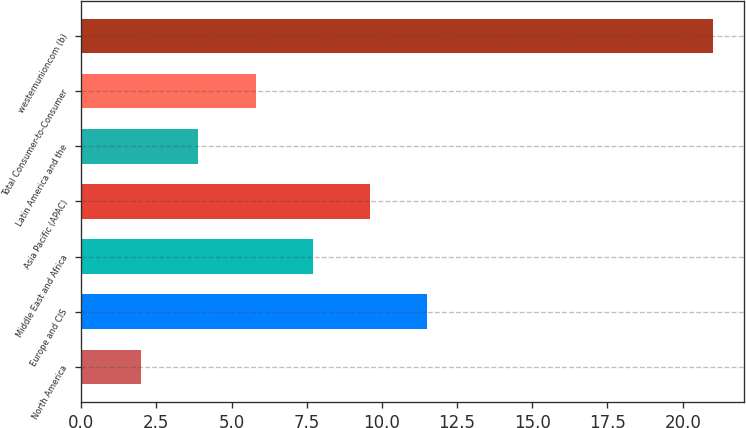<chart> <loc_0><loc_0><loc_500><loc_500><bar_chart><fcel>North America<fcel>Europe and CIS<fcel>Middle East and Africa<fcel>Asia Pacific (APAC)<fcel>Latin America and the<fcel>Total Consumer-to-Consumer<fcel>westernunioncom (b)<nl><fcel>2<fcel>11.5<fcel>7.7<fcel>9.6<fcel>3.9<fcel>5.8<fcel>21<nl></chart> 